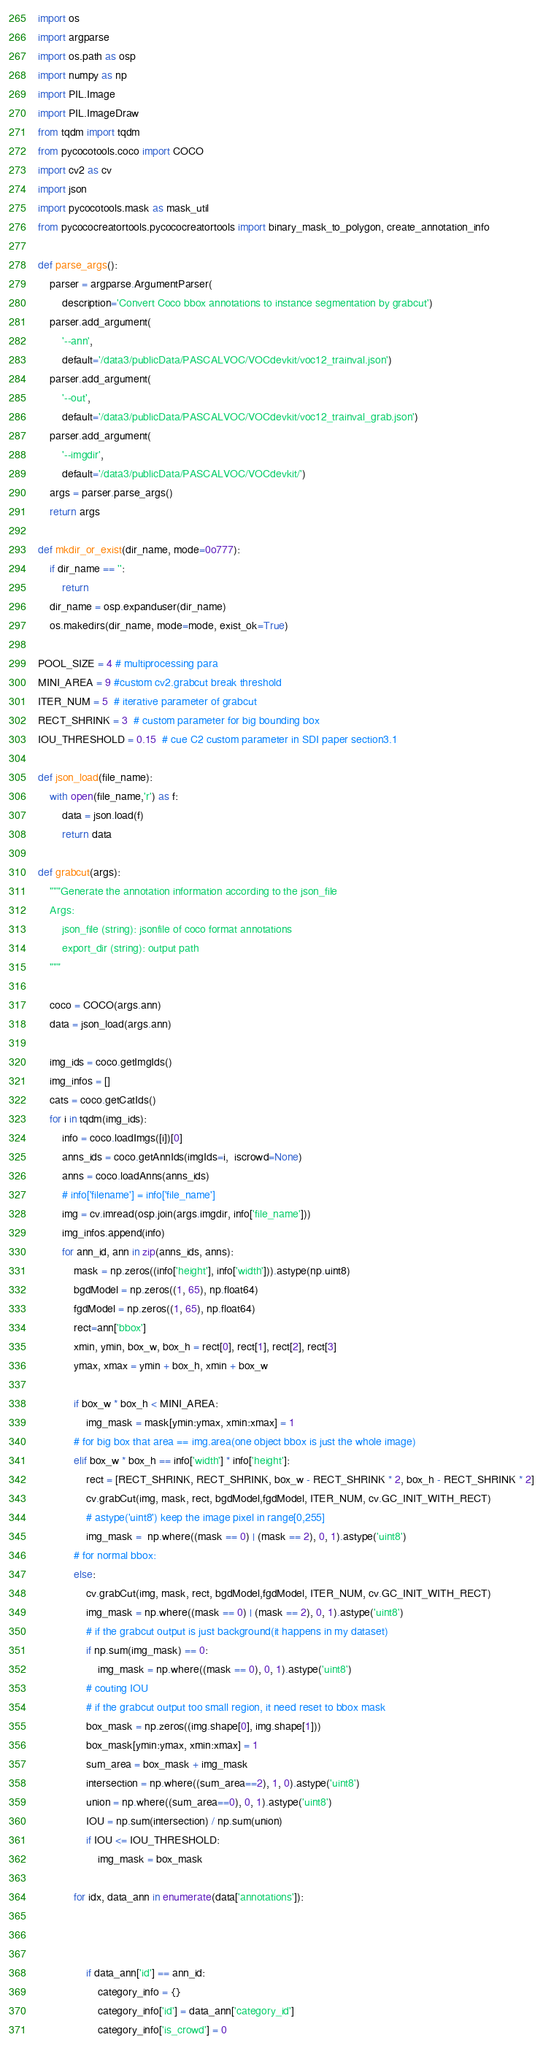<code> <loc_0><loc_0><loc_500><loc_500><_Python_>import os
import argparse
import os.path as osp
import numpy as np
import PIL.Image
import PIL.ImageDraw
from tqdm import tqdm
from pycocotools.coco import COCO
import cv2 as cv
import json
import pycocotools.mask as mask_util
from pycococreatortools.pycococreatortools import binary_mask_to_polygon, create_annotation_info

def parse_args():
    parser = argparse.ArgumentParser(
        description='Convert Coco bbox annotations to instance segmentation by grabcut')
    parser.add_argument(
        '--ann',
        default='/data3/publicData/PASCALVOC/VOCdevkit/voc12_trainval.json')
    parser.add_argument(
        '--out',
        default='/data3/publicData/PASCALVOC/VOCdevkit/voc12_trainval_grab.json')
    parser.add_argument(
        '--imgdir',
        default='/data3/publicData/PASCALVOC/VOCdevkit/')
    args = parser.parse_args()
    return args
 
def mkdir_or_exist(dir_name, mode=0o777):
    if dir_name == '':
        return
    dir_name = osp.expanduser(dir_name)
    os.makedirs(dir_name, mode=mode, exist_ok=True)

POOL_SIZE = 4 # multiprocessing para
MINI_AREA = 9 #custom cv2.grabcut break threshold
ITER_NUM = 5  # iterative parameter of grabcut
RECT_SHRINK = 3  # custom parameter for big bounding box 
IOU_THRESHOLD = 0.15  # cue C2 custom parameter in SDI paper section3.1

def json_load(file_name):
    with open(file_name,'r') as f:
        data = json.load(f)
        return data

def grabcut(args):
    """Generate the annotation information according to the json_file
    Args:
        json_file (string): jsonfile of coco format annotations
        export_dir (string): output path
    """

    coco = COCO(args.ann)
    data = json_load(args.ann)

    img_ids = coco.getImgIds()
    img_infos = []
    cats = coco.getCatIds()
    for i in tqdm(img_ids):
        info = coco.loadImgs([i])[0]
        anns_ids = coco.getAnnIds(imgIds=i,  iscrowd=None)
        anns = coco.loadAnns(anns_ids)
        # info['filename'] = info['file_name']
        img = cv.imread(osp.join(args.imgdir, info['file_name']))
        img_infos.append(info)      
        for ann_id, ann in zip(anns_ids, anns):
            mask = np.zeros((info['height'], info['width'])).astype(np.uint8)      
            bgdModel = np.zeros((1, 65), np.float64)
            fgdModel = np.zeros((1, 65), np.float64)
            rect=ann['bbox']
            xmin, ymin, box_w, box_h = rect[0], rect[1], rect[2], rect[3]
            ymax, xmax = ymin + box_h, xmin + box_w

            if box_w * box_h < MINI_AREA:
                img_mask = mask[ymin:ymax, xmin:xmax] = 1
            # for big box that area == img.area(one object bbox is just the whole image)
            elif box_w * box_h == info['width'] * info['height']:
                rect = [RECT_SHRINK, RECT_SHRINK, box_w - RECT_SHRINK * 2, box_h - RECT_SHRINK * 2]
                cv.grabCut(img, mask, rect, bgdModel,fgdModel, ITER_NUM, cv.GC_INIT_WITH_RECT)
                # astype('uint8') keep the image pixel in range[0,255]
                img_mask =  np.where((mask == 0) | (mask == 2), 0, 1).astype('uint8')
            # for normal bbox:
            else:
                cv.grabCut(img, mask, rect, bgdModel,fgdModel, ITER_NUM, cv.GC_INIT_WITH_RECT)
                img_mask = np.where((mask == 0) | (mask == 2), 0, 1).astype('uint8')
                # if the grabcut output is just background(it happens in my dataset)
                if np.sum(img_mask) == 0:
                    img_mask = np.where((mask == 0), 0, 1).astype('uint8')
                # couting IOU
                # if the grabcut output too small region, it need reset to bbox mask
                box_mask = np.zeros((img.shape[0], img.shape[1]))
                box_mask[ymin:ymax, xmin:xmax] = 1
                sum_area = box_mask + img_mask
                intersection = np.where((sum_area==2), 1, 0).astype('uint8')
                union = np.where((sum_area==0), 0, 1).astype('uint8')
                IOU = np.sum(intersection) / np.sum(union)
                if IOU <= IOU_THRESHOLD:
                    img_mask = box_mask
            
            for idx, data_ann in enumerate(data['annotations']):

                

                if data_ann['id'] == ann_id:   
                    category_info = {}
                    category_info['id'] = data_ann['category_id']
                    category_info['is_crowd'] = 0</code> 